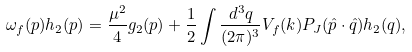Convert formula to latex. <formula><loc_0><loc_0><loc_500><loc_500>\omega _ { f } ( p ) h _ { 2 } ( p ) = \frac { \mu ^ { 2 } } { 4 } g _ { 2 } ( p ) + \frac { 1 } { 2 } \int \frac { d ^ { 3 } q } { ( 2 \pi ) ^ { 3 } } V _ { f } ( k ) P _ { J } ( \hat { p } \cdot \hat { q } ) h _ { 2 } ( q ) ,</formula> 